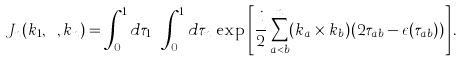Convert formula to latex. <formula><loc_0><loc_0><loc_500><loc_500>J _ { n } ( k _ { 1 } , \cdots , k _ { n } ) = \int _ { 0 } ^ { 1 } d \tau _ { 1 } \cdots \int _ { 0 } ^ { 1 } d \tau _ { n } \, \exp \left [ \frac { i } { 2 } \sum _ { a < b } ^ { n } ( k _ { a } \times k _ { b } ) ( 2 \tau _ { a b } - \epsilon ( \tau _ { a b } ) ) \right ] .</formula> 